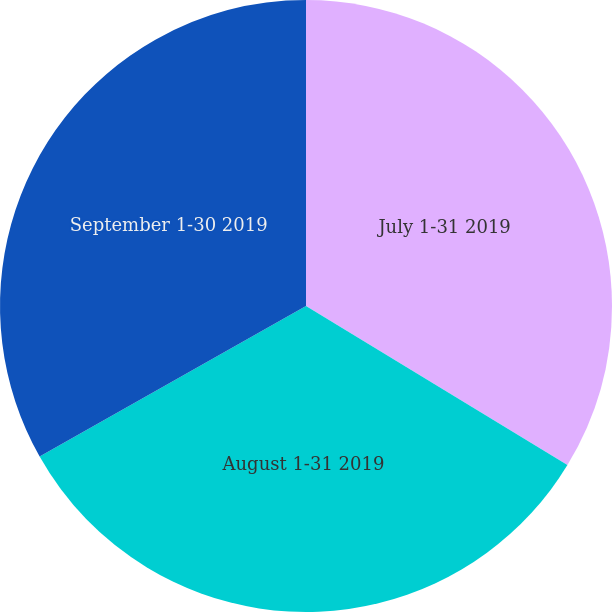<chart> <loc_0><loc_0><loc_500><loc_500><pie_chart><fcel>July 1-31 2019<fcel>August 1-31 2019<fcel>September 1-30 2019<nl><fcel>33.7%<fcel>33.11%<fcel>33.19%<nl></chart> 